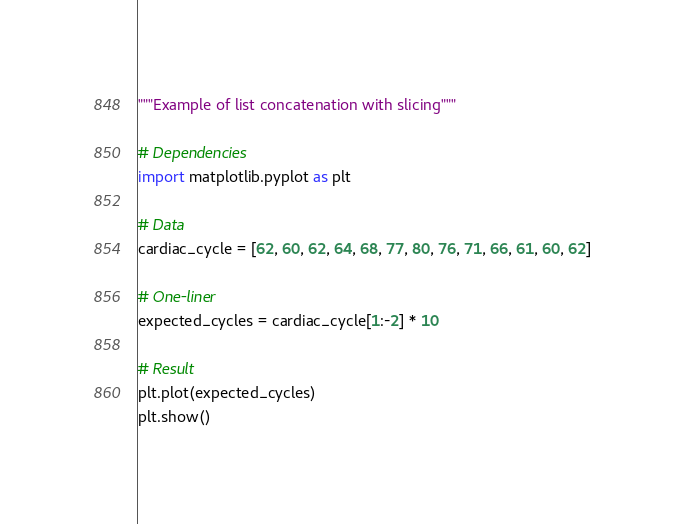<code> <loc_0><loc_0><loc_500><loc_500><_Python_>"""Example of list concatenation with slicing"""

# Dependencies
import matplotlib.pyplot as plt

# Data
cardiac_cycle = [62, 60, 62, 64, 68, 77, 80, 76, 71, 66, 61, 60, 62]

# One-liner
expected_cycles = cardiac_cycle[1:-2] * 10

# Result
plt.plot(expected_cycles)
plt.show()</code> 